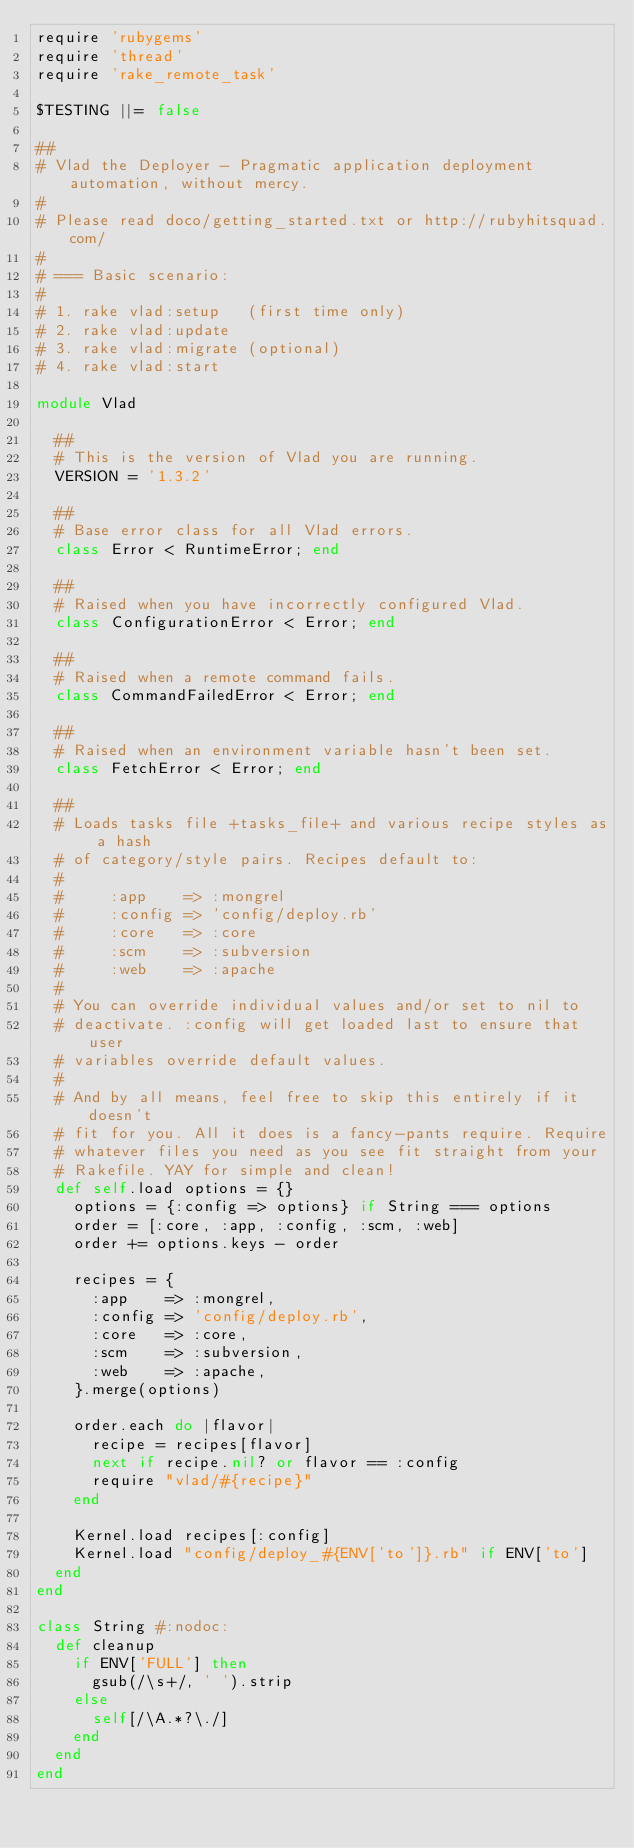<code> <loc_0><loc_0><loc_500><loc_500><_Ruby_>require 'rubygems'
require 'thread'
require 'rake_remote_task'

$TESTING ||= false

##
# Vlad the Deployer - Pragmatic application deployment automation, without mercy.
#
# Please read doco/getting_started.txt or http://rubyhitsquad.com/
#
# === Basic scenario:
#
# 1. rake vlad:setup   (first time only)
# 2. rake vlad:update
# 3. rake vlad:migrate (optional)
# 4. rake vlad:start

module Vlad

  ##
  # This is the version of Vlad you are running.
  VERSION = '1.3.2'

  ##
  # Base error class for all Vlad errors.
  class Error < RuntimeError; end

  ##
  # Raised when you have incorrectly configured Vlad.
  class ConfigurationError < Error; end

  ##
  # Raised when a remote command fails.
  class CommandFailedError < Error; end

  ##
  # Raised when an environment variable hasn't been set.
  class FetchError < Error; end

  ##
  # Loads tasks file +tasks_file+ and various recipe styles as a hash
  # of category/style pairs. Recipes default to:
  #
  #     :app    => :mongrel
  #     :config => 'config/deploy.rb'
  #     :core   => :core
  #     :scm    => :subversion
  #     :web    => :apache
  #
  # You can override individual values and/or set to nil to
  # deactivate. :config will get loaded last to ensure that user
  # variables override default values.
  #
  # And by all means, feel free to skip this entirely if it doesn't
  # fit for you. All it does is a fancy-pants require. Require
  # whatever files you need as you see fit straight from your
  # Rakefile. YAY for simple and clean!
  def self.load options = {}
    options = {:config => options} if String === options
    order = [:core, :app, :config, :scm, :web]
    order += options.keys - order

    recipes = {
      :app    => :mongrel,
      :config => 'config/deploy.rb',
      :core   => :core,
      :scm    => :subversion,
      :web    => :apache,
    }.merge(options)

    order.each do |flavor|
      recipe = recipes[flavor]
      next if recipe.nil? or flavor == :config
      require "vlad/#{recipe}"
    end

    Kernel.load recipes[:config]
    Kernel.load "config/deploy_#{ENV['to']}.rb" if ENV['to']
  end
end

class String #:nodoc:
  def cleanup
    if ENV['FULL'] then
      gsub(/\s+/, ' ').strip
    else
      self[/\A.*?\./]
    end
  end
end
</code> 